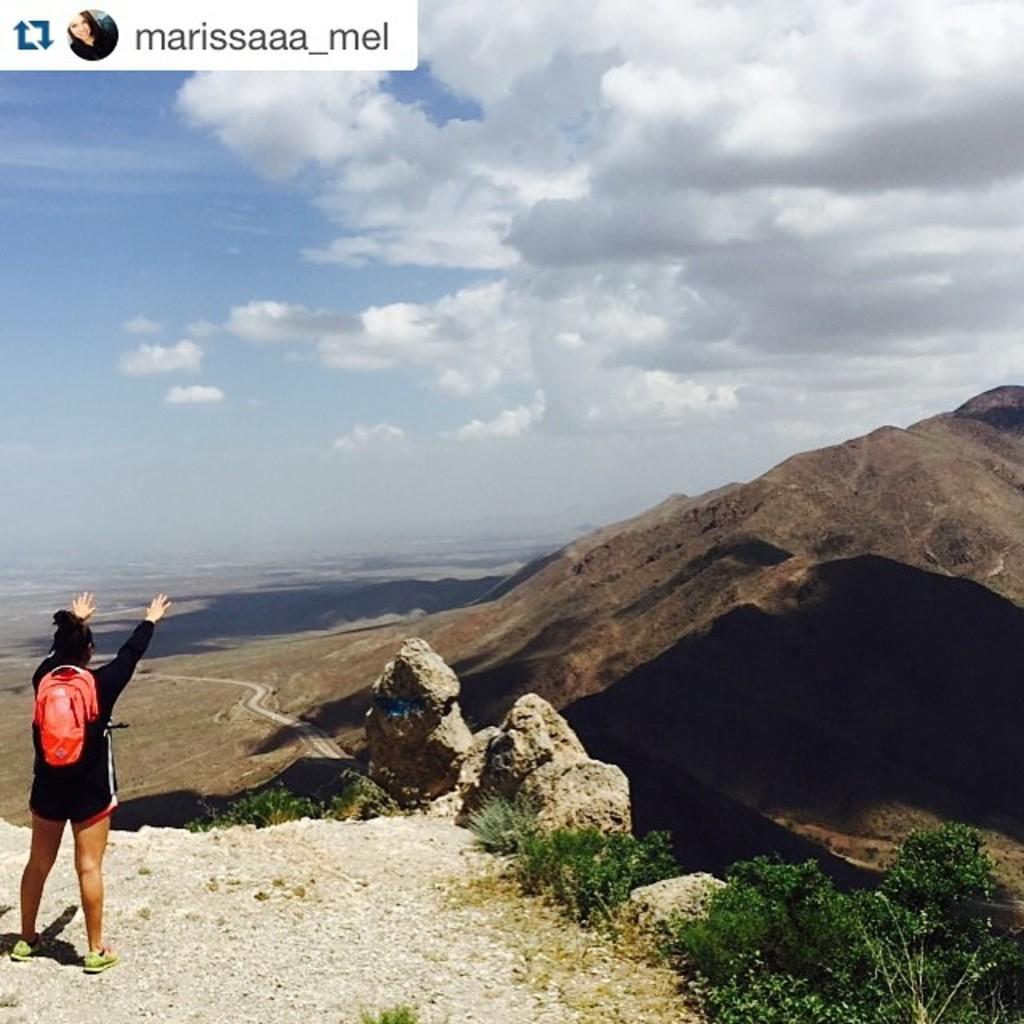Can you describe this image briefly? In the picture we can see a man standing and on the hill surface wearing a bag and raising his hands and besides him we can see some rocks, plants and behind it, we can see a rocky hill and behind it we can see water and in the background we can see a sky with clouds. 